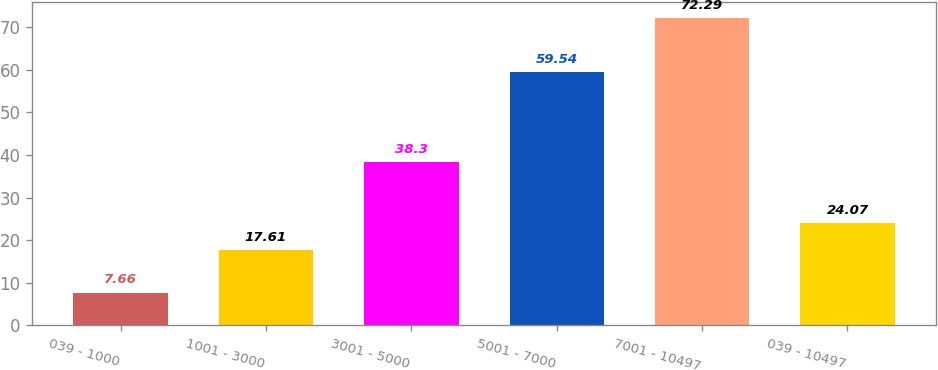Convert chart to OTSL. <chart><loc_0><loc_0><loc_500><loc_500><bar_chart><fcel>039 - 1000<fcel>1001 - 3000<fcel>3001 - 5000<fcel>5001 - 7000<fcel>7001 - 10497<fcel>039 - 10497<nl><fcel>7.66<fcel>17.61<fcel>38.3<fcel>59.54<fcel>72.29<fcel>24.07<nl></chart> 